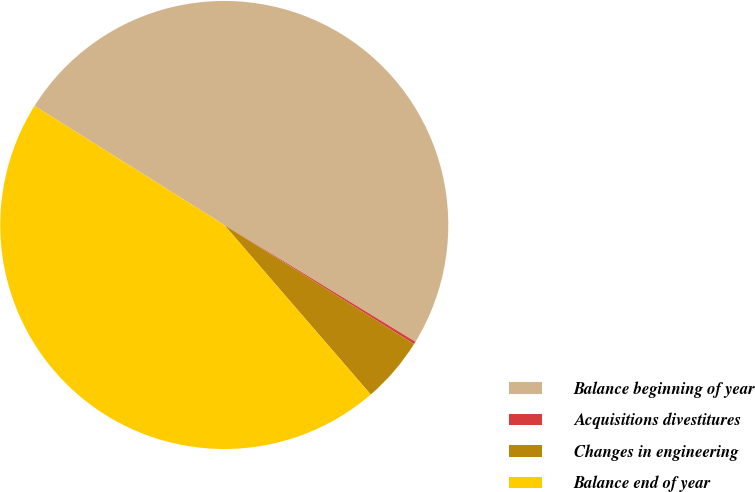Convert chart to OTSL. <chart><loc_0><loc_0><loc_500><loc_500><pie_chart><fcel>Balance beginning of year<fcel>Acquisitions divestitures<fcel>Changes in engineering<fcel>Balance end of year<nl><fcel>49.81%<fcel>0.19%<fcel>4.74%<fcel>45.26%<nl></chart> 